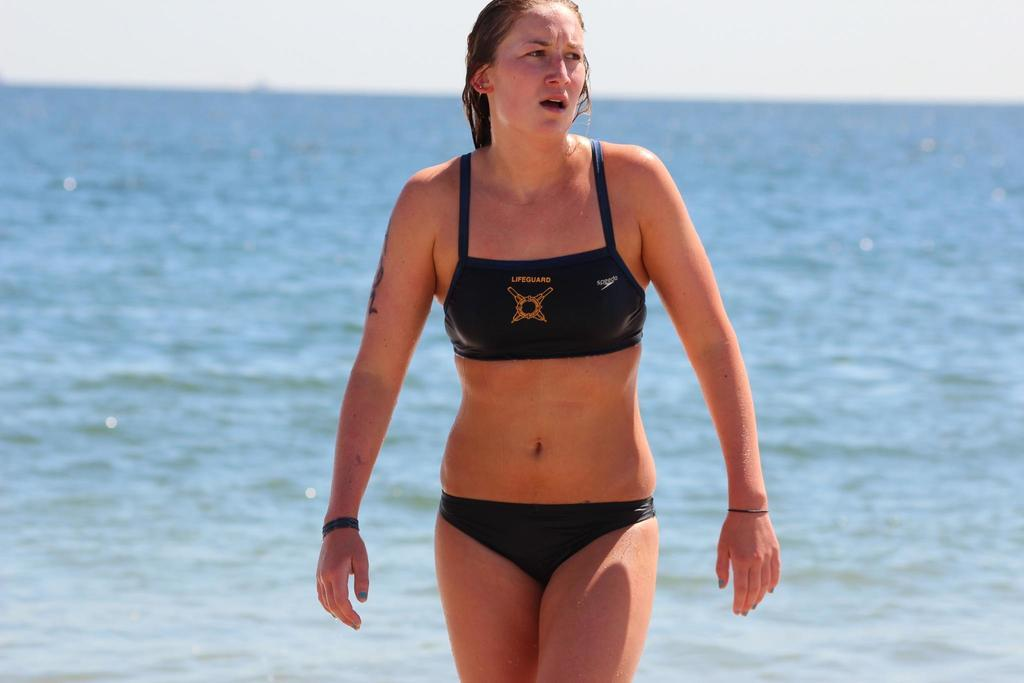Who is in the image? There is a woman in the image. What is the woman wearing? The woman is wearing a black swim dress. What is the woman doing in the image? The woman is standing. What can be seen in the background of the image? There is an ocean and the sky visible in the background of the image. What type of bone can be seen in the woman's hand in the image? There is no bone visible in the woman's hand in the image. Is the woman in the image at a hospital? There is no indication in the image that the woman is at a hospital. 